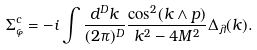<formula> <loc_0><loc_0><loc_500><loc_500>\Sigma _ { \varphi } ^ { c } = - i \int \frac { d ^ { D } k } { ( 2 \pi ) ^ { D } } \frac { \cos ^ { 2 } ( k \wedge p ) } { k ^ { 2 } - 4 M ^ { 2 } } \Delta _ { \lambda } ( k ) .</formula> 